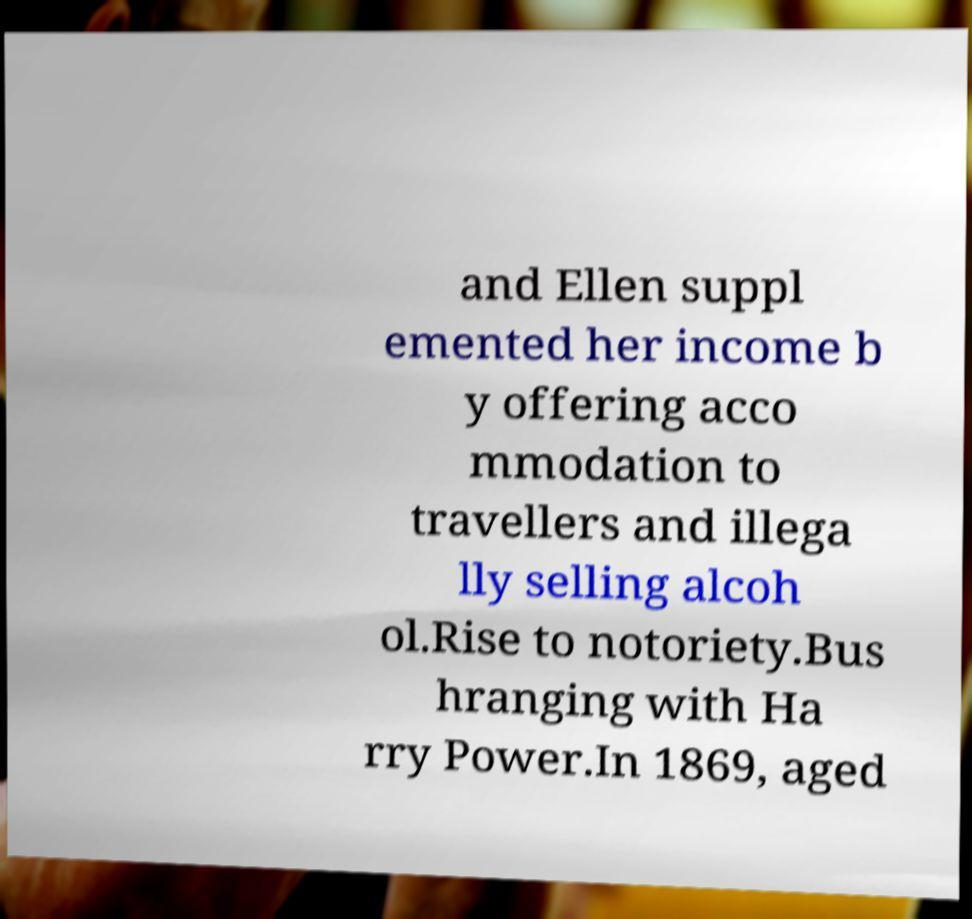Could you extract and type out the text from this image? and Ellen suppl emented her income b y offering acco mmodation to travellers and illega lly selling alcoh ol.Rise to notoriety.Bus hranging with Ha rry Power.In 1869, aged 